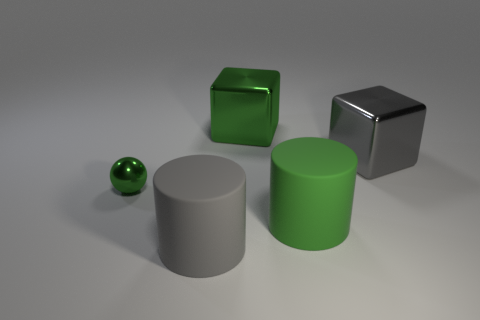Add 1 large cyan rubber blocks. How many objects exist? 6 Subtract all balls. How many objects are left? 4 Add 2 tiny yellow spheres. How many tiny yellow spheres exist? 2 Subtract 0 blue blocks. How many objects are left? 5 Subtract all green metal things. Subtract all green blocks. How many objects are left? 2 Add 4 big cylinders. How many big cylinders are left? 6 